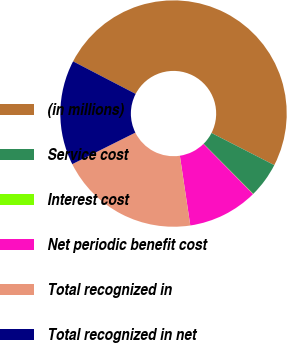<chart> <loc_0><loc_0><loc_500><loc_500><pie_chart><fcel>(in millions)<fcel>Service cost<fcel>Interest cost<fcel>Net periodic benefit cost<fcel>Total recognized in<fcel>Total recognized in net<nl><fcel>49.9%<fcel>5.03%<fcel>0.05%<fcel>10.02%<fcel>19.99%<fcel>15.0%<nl></chart> 